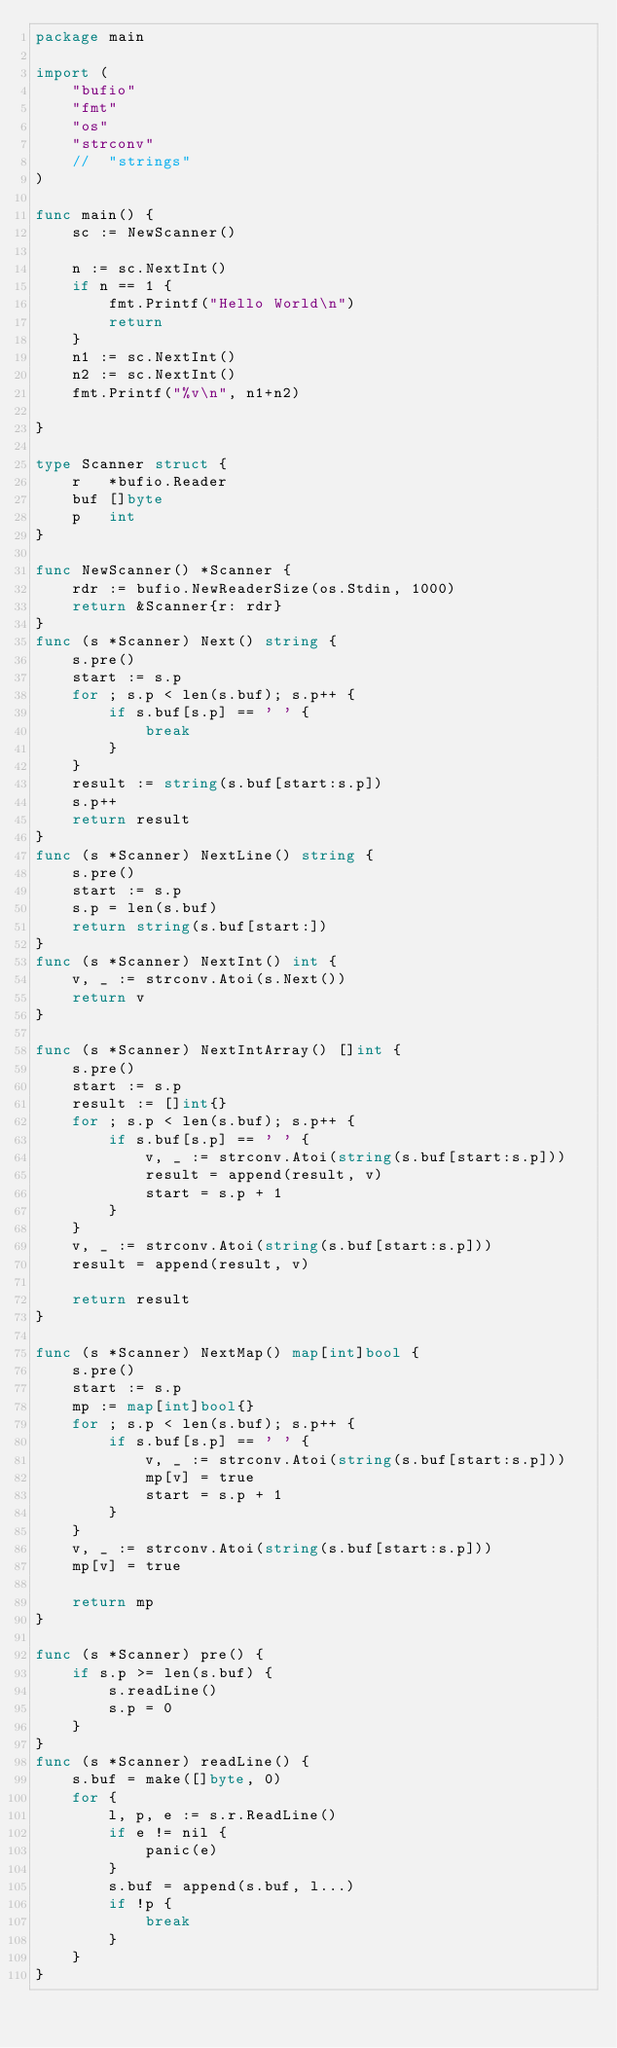Convert code to text. <code><loc_0><loc_0><loc_500><loc_500><_Go_>package main

import (
	"bufio"
	"fmt"
	"os"
	"strconv"
	//	"strings"
)

func main() {
	sc := NewScanner()

	n := sc.NextInt()
	if n == 1 {
		fmt.Printf("Hello World\n")
		return
	}
	n1 := sc.NextInt()
	n2 := sc.NextInt()
	fmt.Printf("%v\n", n1+n2)

}

type Scanner struct {
	r   *bufio.Reader
	buf []byte
	p   int
}

func NewScanner() *Scanner {
	rdr := bufio.NewReaderSize(os.Stdin, 1000)
	return &Scanner{r: rdr}
}
func (s *Scanner) Next() string {
	s.pre()
	start := s.p
	for ; s.p < len(s.buf); s.p++ {
		if s.buf[s.p] == ' ' {
			break
		}
	}
	result := string(s.buf[start:s.p])
	s.p++
	return result
}
func (s *Scanner) NextLine() string {
	s.pre()
	start := s.p
	s.p = len(s.buf)
	return string(s.buf[start:])
}
func (s *Scanner) NextInt() int {
	v, _ := strconv.Atoi(s.Next())
	return v
}

func (s *Scanner) NextIntArray() []int {
	s.pre()
	start := s.p
	result := []int{}
	for ; s.p < len(s.buf); s.p++ {
		if s.buf[s.p] == ' ' {
			v, _ := strconv.Atoi(string(s.buf[start:s.p]))
			result = append(result, v)
			start = s.p + 1
		}
	}
	v, _ := strconv.Atoi(string(s.buf[start:s.p]))
	result = append(result, v)

	return result
}

func (s *Scanner) NextMap() map[int]bool {
	s.pre()
	start := s.p
	mp := map[int]bool{}
	for ; s.p < len(s.buf); s.p++ {
		if s.buf[s.p] == ' ' {
			v, _ := strconv.Atoi(string(s.buf[start:s.p]))
			mp[v] = true
			start = s.p + 1
		}
	}
	v, _ := strconv.Atoi(string(s.buf[start:s.p]))
	mp[v] = true

	return mp
}

func (s *Scanner) pre() {
	if s.p >= len(s.buf) {
		s.readLine()
		s.p = 0
	}
}
func (s *Scanner) readLine() {
	s.buf = make([]byte, 0)
	for {
		l, p, e := s.r.ReadLine()
		if e != nil {
			panic(e)
		}
		s.buf = append(s.buf, l...)
		if !p {
			break
		}
	}
}
</code> 